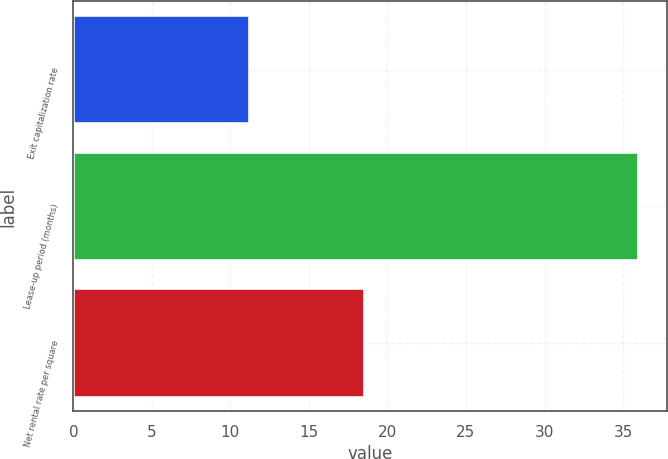Convert chart. <chart><loc_0><loc_0><loc_500><loc_500><bar_chart><fcel>Exit capitalization rate<fcel>Lease-up period (months)<fcel>Net rental rate per square<nl><fcel>11.25<fcel>36<fcel>18.54<nl></chart> 